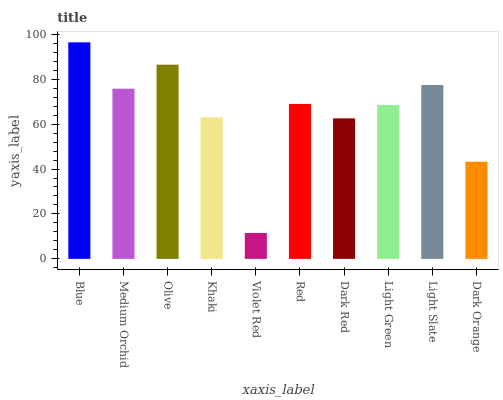Is Violet Red the minimum?
Answer yes or no. Yes. Is Blue the maximum?
Answer yes or no. Yes. Is Medium Orchid the minimum?
Answer yes or no. No. Is Medium Orchid the maximum?
Answer yes or no. No. Is Blue greater than Medium Orchid?
Answer yes or no. Yes. Is Medium Orchid less than Blue?
Answer yes or no. Yes. Is Medium Orchid greater than Blue?
Answer yes or no. No. Is Blue less than Medium Orchid?
Answer yes or no. No. Is Red the high median?
Answer yes or no. Yes. Is Light Green the low median?
Answer yes or no. Yes. Is Violet Red the high median?
Answer yes or no. No. Is Medium Orchid the low median?
Answer yes or no. No. 